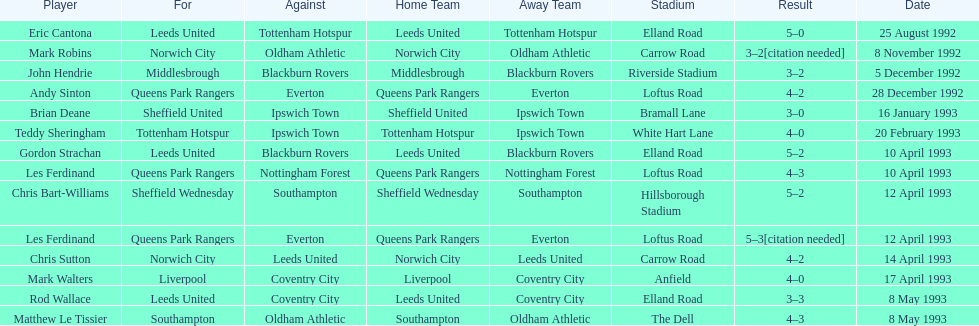Who does john hendrie play for? Middlesbrough. 